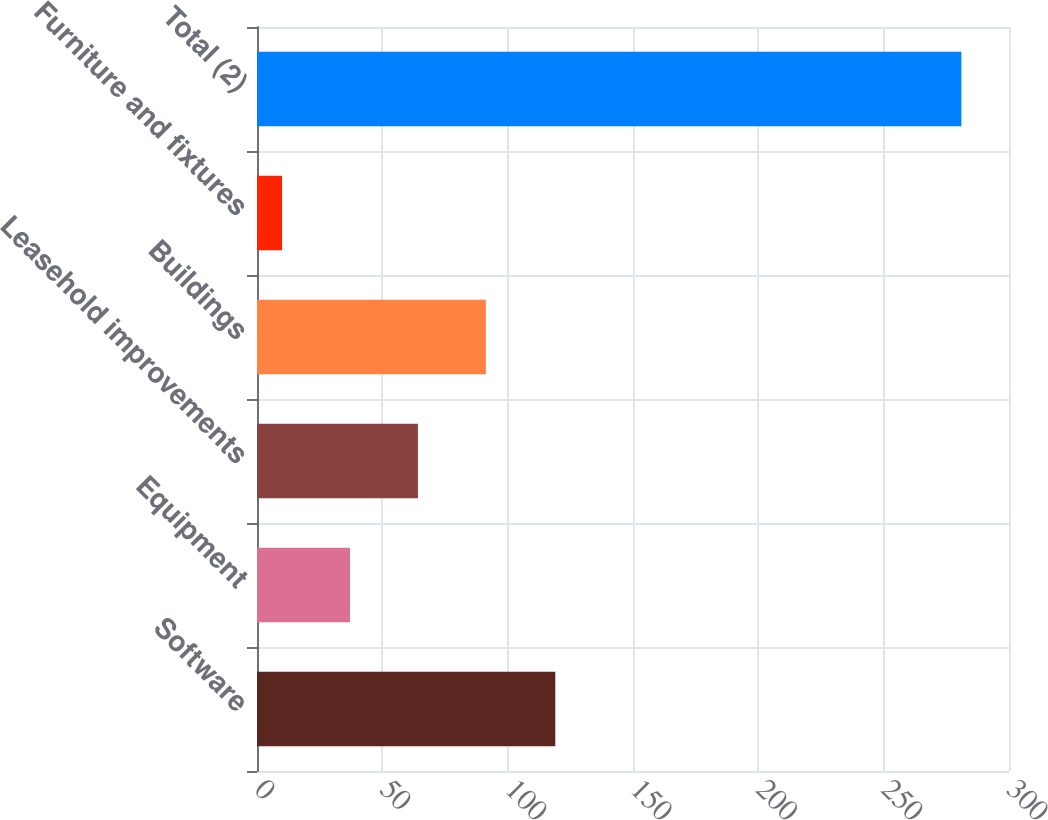Convert chart to OTSL. <chart><loc_0><loc_0><loc_500><loc_500><bar_chart><fcel>Software<fcel>Equipment<fcel>Leasehold improvements<fcel>Buildings<fcel>Furniture and fixtures<fcel>Total (2)<nl><fcel>119<fcel>37.1<fcel>64.2<fcel>91.3<fcel>10<fcel>281<nl></chart> 